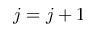<formula> <loc_0><loc_0><loc_500><loc_500>j = j + 1</formula> 